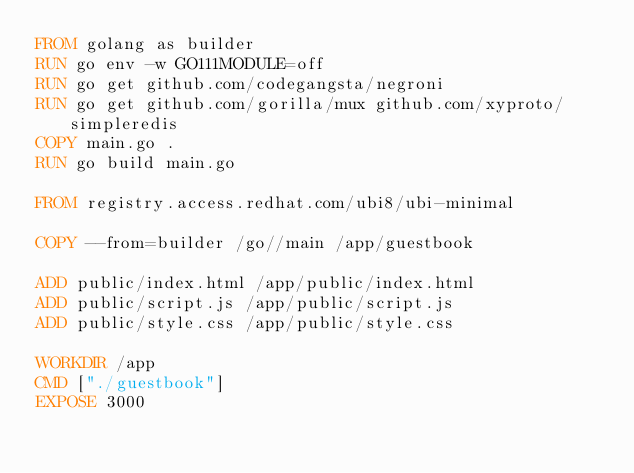Convert code to text. <code><loc_0><loc_0><loc_500><loc_500><_Dockerfile_>FROM golang as builder
RUN go env -w GO111MODULE=off
RUN go get github.com/codegangsta/negroni
RUN go get github.com/gorilla/mux github.com/xyproto/simpleredis
COPY main.go .
RUN go build main.go

FROM registry.access.redhat.com/ubi8/ubi-minimal

COPY --from=builder /go//main /app/guestbook

ADD public/index.html /app/public/index.html
ADD public/script.js /app/public/script.js
ADD public/style.css /app/public/style.css

WORKDIR /app
CMD ["./guestbook"]
EXPOSE 3000
</code> 